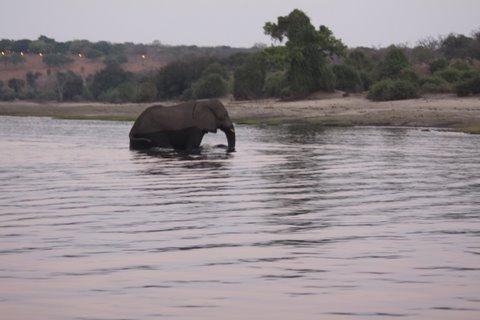What type of animal is in the river?
Keep it brief. Elephant. Is there a man riding the elephant?
Write a very short answer. No. How many animals are in the picture?
Short answer required. 1. How many elephants are there?
Quick response, please. 1. What temperature is the air?
Write a very short answer. Warm. Is someone in the water with the elephant?
Be succinct. No. Is this in a zoo?
Give a very brief answer. No. What kind of animal is in this scene?
Answer briefly. Elephant. Can you see the elephant's legs in the photo?
Concise answer only. No. 